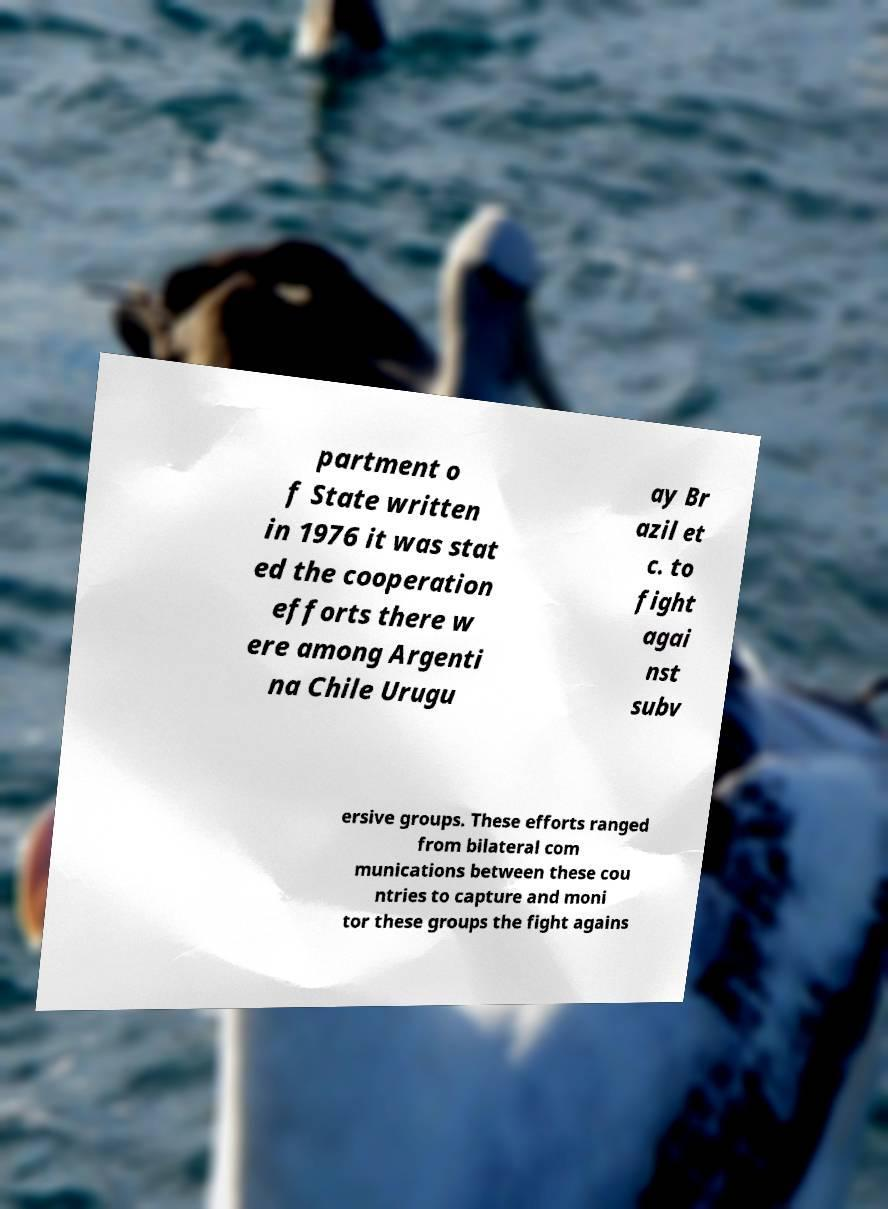Can you accurately transcribe the text from the provided image for me? partment o f State written in 1976 it was stat ed the cooperation efforts there w ere among Argenti na Chile Urugu ay Br azil et c. to fight agai nst subv ersive groups. These efforts ranged from bilateral com munications between these cou ntries to capture and moni tor these groups the fight agains 